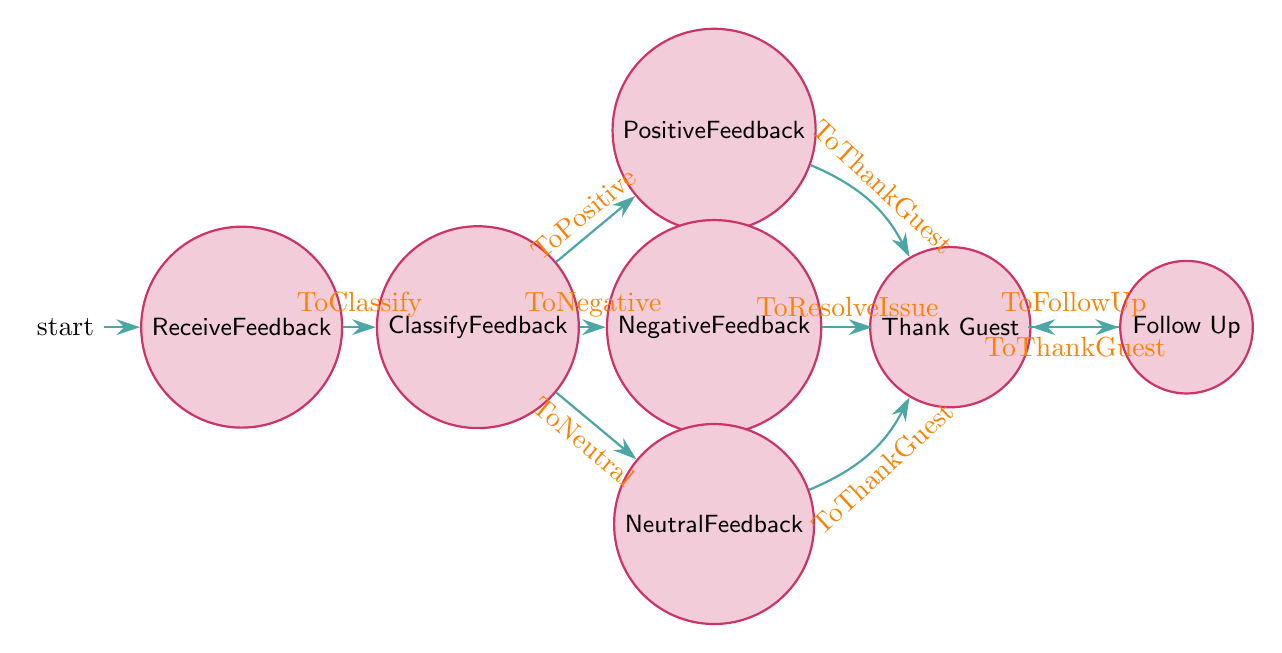What is the initial state of the feedback process? The initial state is where the hotel starts receiving feedback from a guest, labeled as "Receive Feedback."
Answer: Receive Feedback How many feedback types are classified in the diagram? The diagram includes three types of feedback classifications: positive, negative, and neutral. Therefore, the total number is three.
Answer: Three What is the transition to the state that handles negative feedback called? The transition that leads from "Classify Feedback" to "Negative Feedback" is simply named "ToNegative."
Answer: ToNegative What is the next state after resolving an issue? After resolving an issue, the next state indicated is "Follow Up."
Answer: Follow Up Which states lead to thanking the guest? The states that lead to thanking the guest are "Positive Feedback," "Neutral Feedback," and "Follow Up."
Answer: Positive Feedback, Neutral Feedback, Follow Up In which state does the hotel classify the feedback? The classification of the feedback occurs in the state named "Classify Feedback."
Answer: Classify Feedback How many transitions lead from the "Classify Feedback" state? There are three transitions leading from "Classify Feedback" to the respective feedback handling states: positive, negative, and neutral.
Answer: Three What action is taken after negative feedback is processed according to the diagram? The action taken after negative feedback is processed is to resolve the issue as indicated by the transition labeled "ToResolveIssue."
Answer: Resolve Issue What is the final state in this feedback handling process? The final state in the feedback handling process, where all guests are thanked, is "Thank Guest."
Answer: Thank Guest 